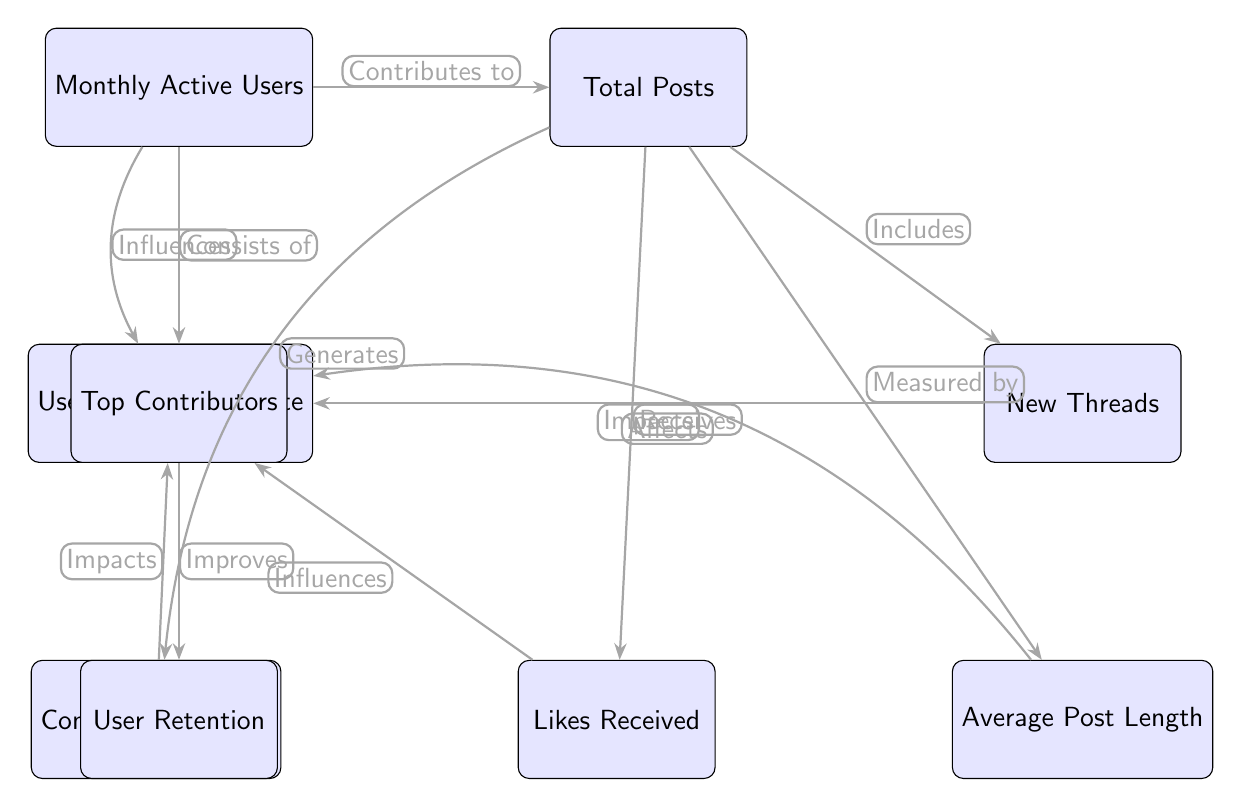What is the first node in the diagram? The first node listed in the diagram as the primary metric is "Monthly Active Users." It is positioned at the top left of the diagram.
Answer: Monthly Active Users How many metrics are shown in the diagram? The diagram includes a total of 9 distinct metrics or nodes, which can be counted by looking at each labeled element within the diagram.
Answer: 9 What does "Total Posts" influence according to the diagram? According to the diagram, "Total Posts" has an influence indicated by an arrow that points to "New Threads," depicting a direct relationship.
Answer: New Threads Which node improves "User Retention"? The node that contributes to improving "User Retention" is "Top Contributors." The arrow from "Top Contributors" to "User Retention" clearly shows this relationship.
Answer: Top Contributors What term describes the relationship between "Monthly Active Users" and "Total Posts"? The relationship is described by the term "Contributes to," as indicated by the arrow connecting these two nodes in the diagram.
Answer: Contributes to How does "Likes Received" impact "User Engagement Rate"? "Likes Received" influences the "User Engagement Rate" through an arrow that demonstrates that it affects this metric. Therefore, it is an important aspect of user interaction.
Answer: Influences What is the bottom node in this diagram? The bottom node in the diagram, representing the flow of information, is "User Retention," which is located at the lowest point of the structure.
Answer: User Retention Which metric is measured by "Average Post Length"? According to the diagram, "Average Post Length" is measured by the metric "Total Posts," connected through the corresponding arrow.
Answer: Total Posts What connects "Total Posts" and "Likes Received"? The connection between "Total Posts" and "Likes Received" is described with the term "Receives," indicating that the posts accumulate likes as a form of interaction.
Answer: Receives 